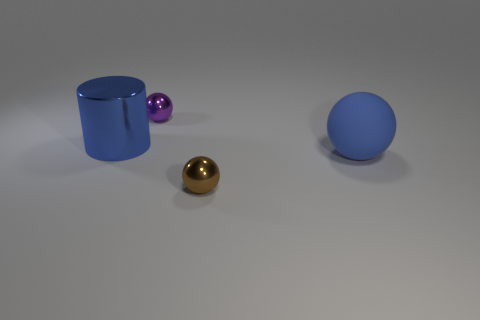How big is the metallic ball in front of the small purple shiny sphere? The metallic ball appears to be approximately twice the diameter of the smaller purple sphere behind it. Without a frame of reference for scale in the image, exact measurements can't be provided, but in relation to the other objects, the golden metallic ball is mid-sized. 